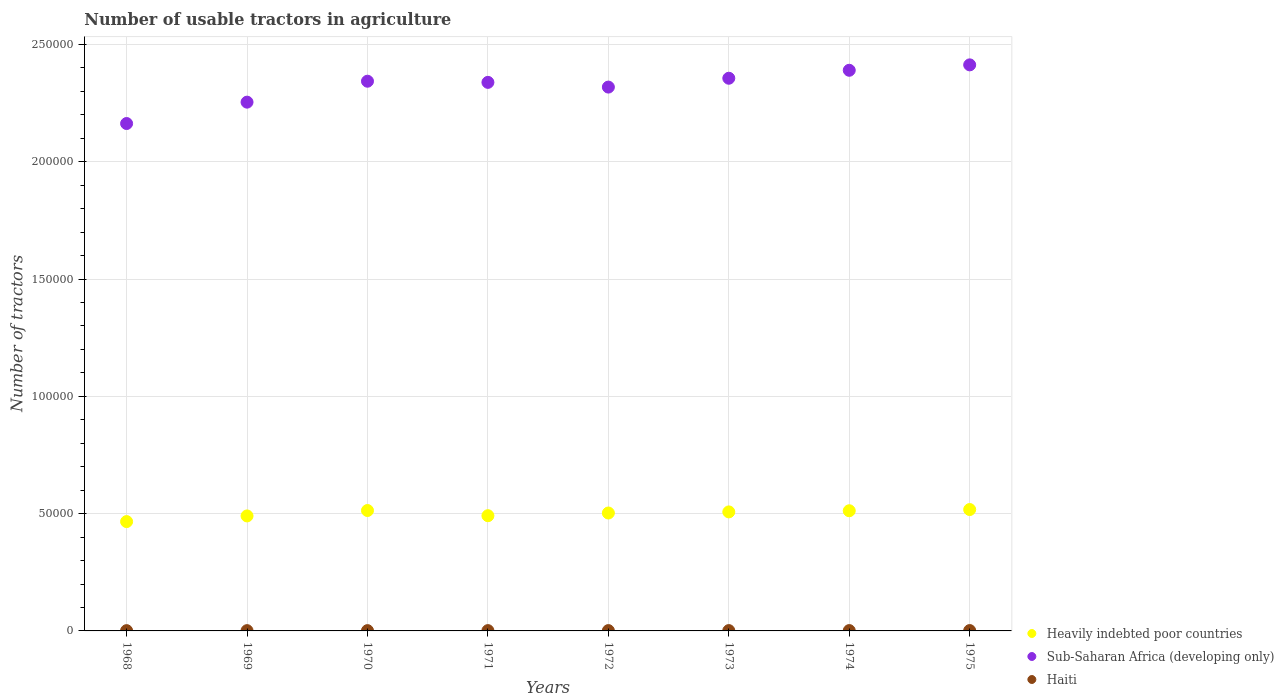Is the number of dotlines equal to the number of legend labels?
Provide a short and direct response. Yes. What is the number of usable tractors in agriculture in Haiti in 1973?
Provide a short and direct response. 140. Across all years, what is the maximum number of usable tractors in agriculture in Heavily indebted poor countries?
Provide a short and direct response. 5.17e+04. Across all years, what is the minimum number of usable tractors in agriculture in Sub-Saharan Africa (developing only)?
Provide a succinct answer. 2.16e+05. In which year was the number of usable tractors in agriculture in Heavily indebted poor countries maximum?
Your answer should be very brief. 1975. In which year was the number of usable tractors in agriculture in Sub-Saharan Africa (developing only) minimum?
Your response must be concise. 1968. What is the total number of usable tractors in agriculture in Sub-Saharan Africa (developing only) in the graph?
Provide a succinct answer. 1.86e+06. What is the difference between the number of usable tractors in agriculture in Sub-Saharan Africa (developing only) in 1969 and that in 1970?
Your response must be concise. -8924. What is the difference between the number of usable tractors in agriculture in Haiti in 1969 and the number of usable tractors in agriculture in Heavily indebted poor countries in 1972?
Ensure brevity in your answer.  -5.01e+04. What is the average number of usable tractors in agriculture in Heavily indebted poor countries per year?
Keep it short and to the point. 5.00e+04. In the year 1974, what is the difference between the number of usable tractors in agriculture in Haiti and number of usable tractors in agriculture in Heavily indebted poor countries?
Your answer should be very brief. -5.11e+04. In how many years, is the number of usable tractors in agriculture in Sub-Saharan Africa (developing only) greater than 40000?
Your answer should be very brief. 8. What is the ratio of the number of usable tractors in agriculture in Heavily indebted poor countries in 1972 to that in 1974?
Give a very brief answer. 0.98. Is the number of usable tractors in agriculture in Sub-Saharan Africa (developing only) in 1970 less than that in 1971?
Make the answer very short. No. Is the difference between the number of usable tractors in agriculture in Haiti in 1970 and 1971 greater than the difference between the number of usable tractors in agriculture in Heavily indebted poor countries in 1970 and 1971?
Provide a short and direct response. No. What is the difference between the highest and the second highest number of usable tractors in agriculture in Heavily indebted poor countries?
Offer a terse response. 417. What is the difference between the highest and the lowest number of usable tractors in agriculture in Heavily indebted poor countries?
Make the answer very short. 5139. In how many years, is the number of usable tractors in agriculture in Heavily indebted poor countries greater than the average number of usable tractors in agriculture in Heavily indebted poor countries taken over all years?
Provide a succinct answer. 5. Is the sum of the number of usable tractors in agriculture in Heavily indebted poor countries in 1970 and 1975 greater than the maximum number of usable tractors in agriculture in Haiti across all years?
Your answer should be very brief. Yes. Is it the case that in every year, the sum of the number of usable tractors in agriculture in Haiti and number of usable tractors in agriculture in Heavily indebted poor countries  is greater than the number of usable tractors in agriculture in Sub-Saharan Africa (developing only)?
Offer a very short reply. No. Is the number of usable tractors in agriculture in Sub-Saharan Africa (developing only) strictly less than the number of usable tractors in agriculture in Haiti over the years?
Give a very brief answer. No. How many dotlines are there?
Your answer should be compact. 3. How many years are there in the graph?
Offer a terse response. 8. What is the difference between two consecutive major ticks on the Y-axis?
Offer a very short reply. 5.00e+04. Does the graph contain grids?
Your response must be concise. Yes. How many legend labels are there?
Give a very brief answer. 3. What is the title of the graph?
Offer a terse response. Number of usable tractors in agriculture. Does "Serbia" appear as one of the legend labels in the graph?
Make the answer very short. No. What is the label or title of the Y-axis?
Your response must be concise. Number of tractors. What is the Number of tractors of Heavily indebted poor countries in 1968?
Your answer should be compact. 4.66e+04. What is the Number of tractors of Sub-Saharan Africa (developing only) in 1968?
Provide a short and direct response. 2.16e+05. What is the Number of tractors in Haiti in 1968?
Your answer should be compact. 115. What is the Number of tractors in Heavily indebted poor countries in 1969?
Your answer should be compact. 4.90e+04. What is the Number of tractors in Sub-Saharan Africa (developing only) in 1969?
Provide a succinct answer. 2.25e+05. What is the Number of tractors of Haiti in 1969?
Ensure brevity in your answer.  120. What is the Number of tractors of Heavily indebted poor countries in 1970?
Your response must be concise. 5.13e+04. What is the Number of tractors of Sub-Saharan Africa (developing only) in 1970?
Provide a short and direct response. 2.34e+05. What is the Number of tractors in Haiti in 1970?
Your response must be concise. 125. What is the Number of tractors in Heavily indebted poor countries in 1971?
Provide a short and direct response. 4.91e+04. What is the Number of tractors in Sub-Saharan Africa (developing only) in 1971?
Your response must be concise. 2.34e+05. What is the Number of tractors in Haiti in 1971?
Offer a terse response. 130. What is the Number of tractors in Heavily indebted poor countries in 1972?
Ensure brevity in your answer.  5.03e+04. What is the Number of tractors in Sub-Saharan Africa (developing only) in 1972?
Provide a short and direct response. 2.32e+05. What is the Number of tractors of Haiti in 1972?
Your answer should be very brief. 135. What is the Number of tractors of Heavily indebted poor countries in 1973?
Your response must be concise. 5.07e+04. What is the Number of tractors of Sub-Saharan Africa (developing only) in 1973?
Your response must be concise. 2.36e+05. What is the Number of tractors in Haiti in 1973?
Your answer should be compact. 140. What is the Number of tractors of Heavily indebted poor countries in 1974?
Keep it short and to the point. 5.12e+04. What is the Number of tractors in Sub-Saharan Africa (developing only) in 1974?
Provide a short and direct response. 2.39e+05. What is the Number of tractors in Haiti in 1974?
Give a very brief answer. 145. What is the Number of tractors in Heavily indebted poor countries in 1975?
Provide a succinct answer. 5.17e+04. What is the Number of tractors in Sub-Saharan Africa (developing only) in 1975?
Provide a succinct answer. 2.41e+05. What is the Number of tractors in Haiti in 1975?
Offer a very short reply. 150. Across all years, what is the maximum Number of tractors of Heavily indebted poor countries?
Make the answer very short. 5.17e+04. Across all years, what is the maximum Number of tractors in Sub-Saharan Africa (developing only)?
Your answer should be compact. 2.41e+05. Across all years, what is the maximum Number of tractors of Haiti?
Make the answer very short. 150. Across all years, what is the minimum Number of tractors of Heavily indebted poor countries?
Your answer should be compact. 4.66e+04. Across all years, what is the minimum Number of tractors in Sub-Saharan Africa (developing only)?
Make the answer very short. 2.16e+05. Across all years, what is the minimum Number of tractors in Haiti?
Your answer should be compact. 115. What is the total Number of tractors in Heavily indebted poor countries in the graph?
Provide a succinct answer. 4.00e+05. What is the total Number of tractors of Sub-Saharan Africa (developing only) in the graph?
Your answer should be compact. 1.86e+06. What is the total Number of tractors of Haiti in the graph?
Provide a short and direct response. 1060. What is the difference between the Number of tractors of Heavily indebted poor countries in 1968 and that in 1969?
Give a very brief answer. -2414. What is the difference between the Number of tractors of Sub-Saharan Africa (developing only) in 1968 and that in 1969?
Your answer should be very brief. -9111. What is the difference between the Number of tractors in Heavily indebted poor countries in 1968 and that in 1970?
Your answer should be compact. -4722. What is the difference between the Number of tractors of Sub-Saharan Africa (developing only) in 1968 and that in 1970?
Offer a very short reply. -1.80e+04. What is the difference between the Number of tractors in Haiti in 1968 and that in 1970?
Offer a terse response. -10. What is the difference between the Number of tractors in Heavily indebted poor countries in 1968 and that in 1971?
Provide a succinct answer. -2512. What is the difference between the Number of tractors of Sub-Saharan Africa (developing only) in 1968 and that in 1971?
Keep it short and to the point. -1.75e+04. What is the difference between the Number of tractors of Haiti in 1968 and that in 1971?
Offer a very short reply. -15. What is the difference between the Number of tractors of Heavily indebted poor countries in 1968 and that in 1972?
Your response must be concise. -3658. What is the difference between the Number of tractors in Sub-Saharan Africa (developing only) in 1968 and that in 1972?
Provide a short and direct response. -1.55e+04. What is the difference between the Number of tractors of Heavily indebted poor countries in 1968 and that in 1973?
Your answer should be compact. -4129. What is the difference between the Number of tractors in Sub-Saharan Africa (developing only) in 1968 and that in 1973?
Provide a short and direct response. -1.93e+04. What is the difference between the Number of tractors of Haiti in 1968 and that in 1973?
Ensure brevity in your answer.  -25. What is the difference between the Number of tractors of Heavily indebted poor countries in 1968 and that in 1974?
Provide a short and direct response. -4622. What is the difference between the Number of tractors in Sub-Saharan Africa (developing only) in 1968 and that in 1974?
Ensure brevity in your answer.  -2.27e+04. What is the difference between the Number of tractors of Heavily indebted poor countries in 1968 and that in 1975?
Provide a succinct answer. -5139. What is the difference between the Number of tractors in Sub-Saharan Africa (developing only) in 1968 and that in 1975?
Your response must be concise. -2.50e+04. What is the difference between the Number of tractors in Haiti in 1968 and that in 1975?
Provide a short and direct response. -35. What is the difference between the Number of tractors of Heavily indebted poor countries in 1969 and that in 1970?
Provide a succinct answer. -2308. What is the difference between the Number of tractors of Sub-Saharan Africa (developing only) in 1969 and that in 1970?
Offer a terse response. -8924. What is the difference between the Number of tractors in Haiti in 1969 and that in 1970?
Keep it short and to the point. -5. What is the difference between the Number of tractors in Heavily indebted poor countries in 1969 and that in 1971?
Provide a succinct answer. -98. What is the difference between the Number of tractors in Sub-Saharan Africa (developing only) in 1969 and that in 1971?
Your response must be concise. -8432. What is the difference between the Number of tractors of Haiti in 1969 and that in 1971?
Offer a very short reply. -10. What is the difference between the Number of tractors in Heavily indebted poor countries in 1969 and that in 1972?
Provide a succinct answer. -1244. What is the difference between the Number of tractors of Sub-Saharan Africa (developing only) in 1969 and that in 1972?
Give a very brief answer. -6420. What is the difference between the Number of tractors in Heavily indebted poor countries in 1969 and that in 1973?
Your answer should be compact. -1715. What is the difference between the Number of tractors of Sub-Saharan Africa (developing only) in 1969 and that in 1973?
Offer a terse response. -1.02e+04. What is the difference between the Number of tractors of Haiti in 1969 and that in 1973?
Keep it short and to the point. -20. What is the difference between the Number of tractors of Heavily indebted poor countries in 1969 and that in 1974?
Give a very brief answer. -2208. What is the difference between the Number of tractors in Sub-Saharan Africa (developing only) in 1969 and that in 1974?
Make the answer very short. -1.36e+04. What is the difference between the Number of tractors in Haiti in 1969 and that in 1974?
Give a very brief answer. -25. What is the difference between the Number of tractors in Heavily indebted poor countries in 1969 and that in 1975?
Make the answer very short. -2725. What is the difference between the Number of tractors in Sub-Saharan Africa (developing only) in 1969 and that in 1975?
Offer a very short reply. -1.59e+04. What is the difference between the Number of tractors in Haiti in 1969 and that in 1975?
Give a very brief answer. -30. What is the difference between the Number of tractors in Heavily indebted poor countries in 1970 and that in 1971?
Give a very brief answer. 2210. What is the difference between the Number of tractors of Sub-Saharan Africa (developing only) in 1970 and that in 1971?
Make the answer very short. 492. What is the difference between the Number of tractors in Heavily indebted poor countries in 1970 and that in 1972?
Your response must be concise. 1064. What is the difference between the Number of tractors of Sub-Saharan Africa (developing only) in 1970 and that in 1972?
Your answer should be compact. 2504. What is the difference between the Number of tractors in Heavily indebted poor countries in 1970 and that in 1973?
Keep it short and to the point. 593. What is the difference between the Number of tractors of Sub-Saharan Africa (developing only) in 1970 and that in 1973?
Provide a succinct answer. -1264. What is the difference between the Number of tractors of Haiti in 1970 and that in 1973?
Your answer should be compact. -15. What is the difference between the Number of tractors of Sub-Saharan Africa (developing only) in 1970 and that in 1974?
Provide a short and direct response. -4661. What is the difference between the Number of tractors of Haiti in 1970 and that in 1974?
Give a very brief answer. -20. What is the difference between the Number of tractors of Heavily indebted poor countries in 1970 and that in 1975?
Provide a short and direct response. -417. What is the difference between the Number of tractors in Sub-Saharan Africa (developing only) in 1970 and that in 1975?
Ensure brevity in your answer.  -6969. What is the difference between the Number of tractors of Haiti in 1970 and that in 1975?
Provide a succinct answer. -25. What is the difference between the Number of tractors of Heavily indebted poor countries in 1971 and that in 1972?
Your answer should be compact. -1146. What is the difference between the Number of tractors of Sub-Saharan Africa (developing only) in 1971 and that in 1972?
Make the answer very short. 2012. What is the difference between the Number of tractors of Haiti in 1971 and that in 1972?
Provide a succinct answer. -5. What is the difference between the Number of tractors in Heavily indebted poor countries in 1971 and that in 1973?
Offer a terse response. -1617. What is the difference between the Number of tractors in Sub-Saharan Africa (developing only) in 1971 and that in 1973?
Offer a very short reply. -1756. What is the difference between the Number of tractors in Heavily indebted poor countries in 1971 and that in 1974?
Provide a short and direct response. -2110. What is the difference between the Number of tractors in Sub-Saharan Africa (developing only) in 1971 and that in 1974?
Your answer should be very brief. -5153. What is the difference between the Number of tractors in Heavily indebted poor countries in 1971 and that in 1975?
Offer a very short reply. -2627. What is the difference between the Number of tractors in Sub-Saharan Africa (developing only) in 1971 and that in 1975?
Offer a very short reply. -7461. What is the difference between the Number of tractors in Haiti in 1971 and that in 1975?
Your answer should be compact. -20. What is the difference between the Number of tractors in Heavily indebted poor countries in 1972 and that in 1973?
Your answer should be very brief. -471. What is the difference between the Number of tractors in Sub-Saharan Africa (developing only) in 1972 and that in 1973?
Keep it short and to the point. -3768. What is the difference between the Number of tractors in Heavily indebted poor countries in 1972 and that in 1974?
Make the answer very short. -964. What is the difference between the Number of tractors of Sub-Saharan Africa (developing only) in 1972 and that in 1974?
Provide a succinct answer. -7165. What is the difference between the Number of tractors in Haiti in 1972 and that in 1974?
Provide a succinct answer. -10. What is the difference between the Number of tractors in Heavily indebted poor countries in 1972 and that in 1975?
Ensure brevity in your answer.  -1481. What is the difference between the Number of tractors in Sub-Saharan Africa (developing only) in 1972 and that in 1975?
Offer a very short reply. -9473. What is the difference between the Number of tractors in Heavily indebted poor countries in 1973 and that in 1974?
Ensure brevity in your answer.  -493. What is the difference between the Number of tractors in Sub-Saharan Africa (developing only) in 1973 and that in 1974?
Offer a very short reply. -3397. What is the difference between the Number of tractors in Haiti in 1973 and that in 1974?
Offer a terse response. -5. What is the difference between the Number of tractors of Heavily indebted poor countries in 1973 and that in 1975?
Give a very brief answer. -1010. What is the difference between the Number of tractors of Sub-Saharan Africa (developing only) in 1973 and that in 1975?
Ensure brevity in your answer.  -5705. What is the difference between the Number of tractors in Haiti in 1973 and that in 1975?
Your answer should be compact. -10. What is the difference between the Number of tractors in Heavily indebted poor countries in 1974 and that in 1975?
Keep it short and to the point. -517. What is the difference between the Number of tractors of Sub-Saharan Africa (developing only) in 1974 and that in 1975?
Offer a terse response. -2308. What is the difference between the Number of tractors in Heavily indebted poor countries in 1968 and the Number of tractors in Sub-Saharan Africa (developing only) in 1969?
Make the answer very short. -1.79e+05. What is the difference between the Number of tractors in Heavily indebted poor countries in 1968 and the Number of tractors in Haiti in 1969?
Ensure brevity in your answer.  4.65e+04. What is the difference between the Number of tractors of Sub-Saharan Africa (developing only) in 1968 and the Number of tractors of Haiti in 1969?
Offer a very short reply. 2.16e+05. What is the difference between the Number of tractors of Heavily indebted poor countries in 1968 and the Number of tractors of Sub-Saharan Africa (developing only) in 1970?
Provide a succinct answer. -1.88e+05. What is the difference between the Number of tractors of Heavily indebted poor countries in 1968 and the Number of tractors of Haiti in 1970?
Give a very brief answer. 4.65e+04. What is the difference between the Number of tractors in Sub-Saharan Africa (developing only) in 1968 and the Number of tractors in Haiti in 1970?
Offer a very short reply. 2.16e+05. What is the difference between the Number of tractors in Heavily indebted poor countries in 1968 and the Number of tractors in Sub-Saharan Africa (developing only) in 1971?
Your answer should be compact. -1.87e+05. What is the difference between the Number of tractors in Heavily indebted poor countries in 1968 and the Number of tractors in Haiti in 1971?
Keep it short and to the point. 4.65e+04. What is the difference between the Number of tractors of Sub-Saharan Africa (developing only) in 1968 and the Number of tractors of Haiti in 1971?
Your answer should be very brief. 2.16e+05. What is the difference between the Number of tractors in Heavily indebted poor countries in 1968 and the Number of tractors in Sub-Saharan Africa (developing only) in 1972?
Give a very brief answer. -1.85e+05. What is the difference between the Number of tractors of Heavily indebted poor countries in 1968 and the Number of tractors of Haiti in 1972?
Make the answer very short. 4.65e+04. What is the difference between the Number of tractors in Sub-Saharan Africa (developing only) in 1968 and the Number of tractors in Haiti in 1972?
Provide a succinct answer. 2.16e+05. What is the difference between the Number of tractors in Heavily indebted poor countries in 1968 and the Number of tractors in Sub-Saharan Africa (developing only) in 1973?
Provide a succinct answer. -1.89e+05. What is the difference between the Number of tractors in Heavily indebted poor countries in 1968 and the Number of tractors in Haiti in 1973?
Offer a very short reply. 4.65e+04. What is the difference between the Number of tractors in Sub-Saharan Africa (developing only) in 1968 and the Number of tractors in Haiti in 1973?
Ensure brevity in your answer.  2.16e+05. What is the difference between the Number of tractors in Heavily indebted poor countries in 1968 and the Number of tractors in Sub-Saharan Africa (developing only) in 1974?
Your answer should be compact. -1.92e+05. What is the difference between the Number of tractors in Heavily indebted poor countries in 1968 and the Number of tractors in Haiti in 1974?
Offer a terse response. 4.65e+04. What is the difference between the Number of tractors in Sub-Saharan Africa (developing only) in 1968 and the Number of tractors in Haiti in 1974?
Give a very brief answer. 2.16e+05. What is the difference between the Number of tractors of Heavily indebted poor countries in 1968 and the Number of tractors of Sub-Saharan Africa (developing only) in 1975?
Offer a terse response. -1.95e+05. What is the difference between the Number of tractors in Heavily indebted poor countries in 1968 and the Number of tractors in Haiti in 1975?
Provide a short and direct response. 4.65e+04. What is the difference between the Number of tractors in Sub-Saharan Africa (developing only) in 1968 and the Number of tractors in Haiti in 1975?
Provide a short and direct response. 2.16e+05. What is the difference between the Number of tractors in Heavily indebted poor countries in 1969 and the Number of tractors in Sub-Saharan Africa (developing only) in 1970?
Ensure brevity in your answer.  -1.85e+05. What is the difference between the Number of tractors of Heavily indebted poor countries in 1969 and the Number of tractors of Haiti in 1970?
Ensure brevity in your answer.  4.89e+04. What is the difference between the Number of tractors in Sub-Saharan Africa (developing only) in 1969 and the Number of tractors in Haiti in 1970?
Ensure brevity in your answer.  2.25e+05. What is the difference between the Number of tractors of Heavily indebted poor countries in 1969 and the Number of tractors of Sub-Saharan Africa (developing only) in 1971?
Make the answer very short. -1.85e+05. What is the difference between the Number of tractors of Heavily indebted poor countries in 1969 and the Number of tractors of Haiti in 1971?
Give a very brief answer. 4.89e+04. What is the difference between the Number of tractors in Sub-Saharan Africa (developing only) in 1969 and the Number of tractors in Haiti in 1971?
Ensure brevity in your answer.  2.25e+05. What is the difference between the Number of tractors in Heavily indebted poor countries in 1969 and the Number of tractors in Sub-Saharan Africa (developing only) in 1972?
Provide a short and direct response. -1.83e+05. What is the difference between the Number of tractors in Heavily indebted poor countries in 1969 and the Number of tractors in Haiti in 1972?
Provide a succinct answer. 4.89e+04. What is the difference between the Number of tractors in Sub-Saharan Africa (developing only) in 1969 and the Number of tractors in Haiti in 1972?
Keep it short and to the point. 2.25e+05. What is the difference between the Number of tractors in Heavily indebted poor countries in 1969 and the Number of tractors in Sub-Saharan Africa (developing only) in 1973?
Offer a terse response. -1.87e+05. What is the difference between the Number of tractors of Heavily indebted poor countries in 1969 and the Number of tractors of Haiti in 1973?
Make the answer very short. 4.89e+04. What is the difference between the Number of tractors of Sub-Saharan Africa (developing only) in 1969 and the Number of tractors of Haiti in 1973?
Offer a terse response. 2.25e+05. What is the difference between the Number of tractors of Heavily indebted poor countries in 1969 and the Number of tractors of Sub-Saharan Africa (developing only) in 1974?
Provide a short and direct response. -1.90e+05. What is the difference between the Number of tractors of Heavily indebted poor countries in 1969 and the Number of tractors of Haiti in 1974?
Ensure brevity in your answer.  4.89e+04. What is the difference between the Number of tractors in Sub-Saharan Africa (developing only) in 1969 and the Number of tractors in Haiti in 1974?
Make the answer very short. 2.25e+05. What is the difference between the Number of tractors of Heavily indebted poor countries in 1969 and the Number of tractors of Sub-Saharan Africa (developing only) in 1975?
Keep it short and to the point. -1.92e+05. What is the difference between the Number of tractors in Heavily indebted poor countries in 1969 and the Number of tractors in Haiti in 1975?
Provide a short and direct response. 4.89e+04. What is the difference between the Number of tractors of Sub-Saharan Africa (developing only) in 1969 and the Number of tractors of Haiti in 1975?
Make the answer very short. 2.25e+05. What is the difference between the Number of tractors of Heavily indebted poor countries in 1970 and the Number of tractors of Sub-Saharan Africa (developing only) in 1971?
Ensure brevity in your answer.  -1.83e+05. What is the difference between the Number of tractors of Heavily indebted poor countries in 1970 and the Number of tractors of Haiti in 1971?
Ensure brevity in your answer.  5.12e+04. What is the difference between the Number of tractors in Sub-Saharan Africa (developing only) in 1970 and the Number of tractors in Haiti in 1971?
Offer a terse response. 2.34e+05. What is the difference between the Number of tractors in Heavily indebted poor countries in 1970 and the Number of tractors in Sub-Saharan Africa (developing only) in 1972?
Offer a very short reply. -1.80e+05. What is the difference between the Number of tractors in Heavily indebted poor countries in 1970 and the Number of tractors in Haiti in 1972?
Offer a terse response. 5.12e+04. What is the difference between the Number of tractors in Sub-Saharan Africa (developing only) in 1970 and the Number of tractors in Haiti in 1972?
Ensure brevity in your answer.  2.34e+05. What is the difference between the Number of tractors of Heavily indebted poor countries in 1970 and the Number of tractors of Sub-Saharan Africa (developing only) in 1973?
Provide a short and direct response. -1.84e+05. What is the difference between the Number of tractors in Heavily indebted poor countries in 1970 and the Number of tractors in Haiti in 1973?
Your answer should be very brief. 5.12e+04. What is the difference between the Number of tractors in Sub-Saharan Africa (developing only) in 1970 and the Number of tractors in Haiti in 1973?
Ensure brevity in your answer.  2.34e+05. What is the difference between the Number of tractors in Heavily indebted poor countries in 1970 and the Number of tractors in Sub-Saharan Africa (developing only) in 1974?
Your response must be concise. -1.88e+05. What is the difference between the Number of tractors in Heavily indebted poor countries in 1970 and the Number of tractors in Haiti in 1974?
Offer a very short reply. 5.12e+04. What is the difference between the Number of tractors in Sub-Saharan Africa (developing only) in 1970 and the Number of tractors in Haiti in 1974?
Make the answer very short. 2.34e+05. What is the difference between the Number of tractors of Heavily indebted poor countries in 1970 and the Number of tractors of Sub-Saharan Africa (developing only) in 1975?
Your response must be concise. -1.90e+05. What is the difference between the Number of tractors in Heavily indebted poor countries in 1970 and the Number of tractors in Haiti in 1975?
Provide a succinct answer. 5.12e+04. What is the difference between the Number of tractors of Sub-Saharan Africa (developing only) in 1970 and the Number of tractors of Haiti in 1975?
Ensure brevity in your answer.  2.34e+05. What is the difference between the Number of tractors of Heavily indebted poor countries in 1971 and the Number of tractors of Sub-Saharan Africa (developing only) in 1972?
Your answer should be very brief. -1.83e+05. What is the difference between the Number of tractors of Heavily indebted poor countries in 1971 and the Number of tractors of Haiti in 1972?
Ensure brevity in your answer.  4.90e+04. What is the difference between the Number of tractors of Sub-Saharan Africa (developing only) in 1971 and the Number of tractors of Haiti in 1972?
Offer a terse response. 2.34e+05. What is the difference between the Number of tractors in Heavily indebted poor countries in 1971 and the Number of tractors in Sub-Saharan Africa (developing only) in 1973?
Give a very brief answer. -1.86e+05. What is the difference between the Number of tractors of Heavily indebted poor countries in 1971 and the Number of tractors of Haiti in 1973?
Provide a short and direct response. 4.90e+04. What is the difference between the Number of tractors of Sub-Saharan Africa (developing only) in 1971 and the Number of tractors of Haiti in 1973?
Your answer should be compact. 2.34e+05. What is the difference between the Number of tractors in Heavily indebted poor countries in 1971 and the Number of tractors in Sub-Saharan Africa (developing only) in 1974?
Give a very brief answer. -1.90e+05. What is the difference between the Number of tractors of Heavily indebted poor countries in 1971 and the Number of tractors of Haiti in 1974?
Offer a terse response. 4.90e+04. What is the difference between the Number of tractors of Sub-Saharan Africa (developing only) in 1971 and the Number of tractors of Haiti in 1974?
Provide a short and direct response. 2.34e+05. What is the difference between the Number of tractors of Heavily indebted poor countries in 1971 and the Number of tractors of Sub-Saharan Africa (developing only) in 1975?
Keep it short and to the point. -1.92e+05. What is the difference between the Number of tractors of Heavily indebted poor countries in 1971 and the Number of tractors of Haiti in 1975?
Keep it short and to the point. 4.90e+04. What is the difference between the Number of tractors of Sub-Saharan Africa (developing only) in 1971 and the Number of tractors of Haiti in 1975?
Offer a terse response. 2.34e+05. What is the difference between the Number of tractors of Heavily indebted poor countries in 1972 and the Number of tractors of Sub-Saharan Africa (developing only) in 1973?
Offer a terse response. -1.85e+05. What is the difference between the Number of tractors in Heavily indebted poor countries in 1972 and the Number of tractors in Haiti in 1973?
Ensure brevity in your answer.  5.01e+04. What is the difference between the Number of tractors of Sub-Saharan Africa (developing only) in 1972 and the Number of tractors of Haiti in 1973?
Offer a very short reply. 2.32e+05. What is the difference between the Number of tractors in Heavily indebted poor countries in 1972 and the Number of tractors in Sub-Saharan Africa (developing only) in 1974?
Offer a terse response. -1.89e+05. What is the difference between the Number of tractors of Heavily indebted poor countries in 1972 and the Number of tractors of Haiti in 1974?
Offer a very short reply. 5.01e+04. What is the difference between the Number of tractors in Sub-Saharan Africa (developing only) in 1972 and the Number of tractors in Haiti in 1974?
Provide a succinct answer. 2.32e+05. What is the difference between the Number of tractors in Heavily indebted poor countries in 1972 and the Number of tractors in Sub-Saharan Africa (developing only) in 1975?
Your answer should be compact. -1.91e+05. What is the difference between the Number of tractors in Heavily indebted poor countries in 1972 and the Number of tractors in Haiti in 1975?
Offer a very short reply. 5.01e+04. What is the difference between the Number of tractors in Sub-Saharan Africa (developing only) in 1972 and the Number of tractors in Haiti in 1975?
Provide a succinct answer. 2.32e+05. What is the difference between the Number of tractors in Heavily indebted poor countries in 1973 and the Number of tractors in Sub-Saharan Africa (developing only) in 1974?
Provide a short and direct response. -1.88e+05. What is the difference between the Number of tractors of Heavily indebted poor countries in 1973 and the Number of tractors of Haiti in 1974?
Offer a very short reply. 5.06e+04. What is the difference between the Number of tractors of Sub-Saharan Africa (developing only) in 1973 and the Number of tractors of Haiti in 1974?
Your response must be concise. 2.35e+05. What is the difference between the Number of tractors in Heavily indebted poor countries in 1973 and the Number of tractors in Sub-Saharan Africa (developing only) in 1975?
Your answer should be compact. -1.91e+05. What is the difference between the Number of tractors of Heavily indebted poor countries in 1973 and the Number of tractors of Haiti in 1975?
Your response must be concise. 5.06e+04. What is the difference between the Number of tractors of Sub-Saharan Africa (developing only) in 1973 and the Number of tractors of Haiti in 1975?
Keep it short and to the point. 2.35e+05. What is the difference between the Number of tractors in Heavily indebted poor countries in 1974 and the Number of tractors in Sub-Saharan Africa (developing only) in 1975?
Your response must be concise. -1.90e+05. What is the difference between the Number of tractors in Heavily indebted poor countries in 1974 and the Number of tractors in Haiti in 1975?
Your answer should be very brief. 5.11e+04. What is the difference between the Number of tractors of Sub-Saharan Africa (developing only) in 1974 and the Number of tractors of Haiti in 1975?
Give a very brief answer. 2.39e+05. What is the average Number of tractors of Heavily indebted poor countries per year?
Make the answer very short. 5.00e+04. What is the average Number of tractors in Sub-Saharan Africa (developing only) per year?
Make the answer very short. 2.32e+05. What is the average Number of tractors of Haiti per year?
Provide a short and direct response. 132.5. In the year 1968, what is the difference between the Number of tractors of Heavily indebted poor countries and Number of tractors of Sub-Saharan Africa (developing only)?
Your response must be concise. -1.70e+05. In the year 1968, what is the difference between the Number of tractors of Heavily indebted poor countries and Number of tractors of Haiti?
Make the answer very short. 4.65e+04. In the year 1968, what is the difference between the Number of tractors of Sub-Saharan Africa (developing only) and Number of tractors of Haiti?
Keep it short and to the point. 2.16e+05. In the year 1969, what is the difference between the Number of tractors of Heavily indebted poor countries and Number of tractors of Sub-Saharan Africa (developing only)?
Ensure brevity in your answer.  -1.76e+05. In the year 1969, what is the difference between the Number of tractors of Heavily indebted poor countries and Number of tractors of Haiti?
Provide a succinct answer. 4.89e+04. In the year 1969, what is the difference between the Number of tractors in Sub-Saharan Africa (developing only) and Number of tractors in Haiti?
Your response must be concise. 2.25e+05. In the year 1970, what is the difference between the Number of tractors in Heavily indebted poor countries and Number of tractors in Sub-Saharan Africa (developing only)?
Your answer should be compact. -1.83e+05. In the year 1970, what is the difference between the Number of tractors in Heavily indebted poor countries and Number of tractors in Haiti?
Provide a succinct answer. 5.12e+04. In the year 1970, what is the difference between the Number of tractors of Sub-Saharan Africa (developing only) and Number of tractors of Haiti?
Keep it short and to the point. 2.34e+05. In the year 1971, what is the difference between the Number of tractors in Heavily indebted poor countries and Number of tractors in Sub-Saharan Africa (developing only)?
Offer a terse response. -1.85e+05. In the year 1971, what is the difference between the Number of tractors of Heavily indebted poor countries and Number of tractors of Haiti?
Offer a very short reply. 4.90e+04. In the year 1971, what is the difference between the Number of tractors of Sub-Saharan Africa (developing only) and Number of tractors of Haiti?
Your response must be concise. 2.34e+05. In the year 1972, what is the difference between the Number of tractors in Heavily indebted poor countries and Number of tractors in Sub-Saharan Africa (developing only)?
Provide a succinct answer. -1.82e+05. In the year 1972, what is the difference between the Number of tractors of Heavily indebted poor countries and Number of tractors of Haiti?
Your response must be concise. 5.01e+04. In the year 1972, what is the difference between the Number of tractors of Sub-Saharan Africa (developing only) and Number of tractors of Haiti?
Give a very brief answer. 2.32e+05. In the year 1973, what is the difference between the Number of tractors in Heavily indebted poor countries and Number of tractors in Sub-Saharan Africa (developing only)?
Ensure brevity in your answer.  -1.85e+05. In the year 1973, what is the difference between the Number of tractors of Heavily indebted poor countries and Number of tractors of Haiti?
Provide a short and direct response. 5.06e+04. In the year 1973, what is the difference between the Number of tractors of Sub-Saharan Africa (developing only) and Number of tractors of Haiti?
Your response must be concise. 2.35e+05. In the year 1974, what is the difference between the Number of tractors of Heavily indebted poor countries and Number of tractors of Sub-Saharan Africa (developing only)?
Give a very brief answer. -1.88e+05. In the year 1974, what is the difference between the Number of tractors in Heavily indebted poor countries and Number of tractors in Haiti?
Your answer should be compact. 5.11e+04. In the year 1974, what is the difference between the Number of tractors in Sub-Saharan Africa (developing only) and Number of tractors in Haiti?
Offer a terse response. 2.39e+05. In the year 1975, what is the difference between the Number of tractors in Heavily indebted poor countries and Number of tractors in Sub-Saharan Africa (developing only)?
Keep it short and to the point. -1.90e+05. In the year 1975, what is the difference between the Number of tractors of Heavily indebted poor countries and Number of tractors of Haiti?
Keep it short and to the point. 5.16e+04. In the year 1975, what is the difference between the Number of tractors of Sub-Saharan Africa (developing only) and Number of tractors of Haiti?
Offer a very short reply. 2.41e+05. What is the ratio of the Number of tractors in Heavily indebted poor countries in 1968 to that in 1969?
Make the answer very short. 0.95. What is the ratio of the Number of tractors in Sub-Saharan Africa (developing only) in 1968 to that in 1969?
Provide a succinct answer. 0.96. What is the ratio of the Number of tractors of Haiti in 1968 to that in 1969?
Offer a terse response. 0.96. What is the ratio of the Number of tractors in Heavily indebted poor countries in 1968 to that in 1970?
Offer a terse response. 0.91. What is the ratio of the Number of tractors in Sub-Saharan Africa (developing only) in 1968 to that in 1970?
Provide a short and direct response. 0.92. What is the ratio of the Number of tractors of Heavily indebted poor countries in 1968 to that in 1971?
Your response must be concise. 0.95. What is the ratio of the Number of tractors of Sub-Saharan Africa (developing only) in 1968 to that in 1971?
Ensure brevity in your answer.  0.93. What is the ratio of the Number of tractors in Haiti in 1968 to that in 1971?
Provide a short and direct response. 0.88. What is the ratio of the Number of tractors of Heavily indebted poor countries in 1968 to that in 1972?
Provide a short and direct response. 0.93. What is the ratio of the Number of tractors of Sub-Saharan Africa (developing only) in 1968 to that in 1972?
Ensure brevity in your answer.  0.93. What is the ratio of the Number of tractors in Haiti in 1968 to that in 1972?
Ensure brevity in your answer.  0.85. What is the ratio of the Number of tractors of Heavily indebted poor countries in 1968 to that in 1973?
Your response must be concise. 0.92. What is the ratio of the Number of tractors in Sub-Saharan Africa (developing only) in 1968 to that in 1973?
Make the answer very short. 0.92. What is the ratio of the Number of tractors in Haiti in 1968 to that in 1973?
Your answer should be very brief. 0.82. What is the ratio of the Number of tractors of Heavily indebted poor countries in 1968 to that in 1974?
Make the answer very short. 0.91. What is the ratio of the Number of tractors of Sub-Saharan Africa (developing only) in 1968 to that in 1974?
Give a very brief answer. 0.91. What is the ratio of the Number of tractors of Haiti in 1968 to that in 1974?
Your response must be concise. 0.79. What is the ratio of the Number of tractors in Heavily indebted poor countries in 1968 to that in 1975?
Offer a very short reply. 0.9. What is the ratio of the Number of tractors in Sub-Saharan Africa (developing only) in 1968 to that in 1975?
Ensure brevity in your answer.  0.9. What is the ratio of the Number of tractors of Haiti in 1968 to that in 1975?
Your answer should be very brief. 0.77. What is the ratio of the Number of tractors in Heavily indebted poor countries in 1969 to that in 1970?
Your response must be concise. 0.95. What is the ratio of the Number of tractors in Sub-Saharan Africa (developing only) in 1969 to that in 1970?
Ensure brevity in your answer.  0.96. What is the ratio of the Number of tractors in Haiti in 1969 to that in 1970?
Keep it short and to the point. 0.96. What is the ratio of the Number of tractors of Sub-Saharan Africa (developing only) in 1969 to that in 1971?
Ensure brevity in your answer.  0.96. What is the ratio of the Number of tractors of Heavily indebted poor countries in 1969 to that in 1972?
Your answer should be very brief. 0.98. What is the ratio of the Number of tractors of Sub-Saharan Africa (developing only) in 1969 to that in 1972?
Keep it short and to the point. 0.97. What is the ratio of the Number of tractors in Heavily indebted poor countries in 1969 to that in 1973?
Make the answer very short. 0.97. What is the ratio of the Number of tractors of Sub-Saharan Africa (developing only) in 1969 to that in 1973?
Offer a very short reply. 0.96. What is the ratio of the Number of tractors in Heavily indebted poor countries in 1969 to that in 1974?
Ensure brevity in your answer.  0.96. What is the ratio of the Number of tractors of Sub-Saharan Africa (developing only) in 1969 to that in 1974?
Ensure brevity in your answer.  0.94. What is the ratio of the Number of tractors of Haiti in 1969 to that in 1974?
Keep it short and to the point. 0.83. What is the ratio of the Number of tractors of Heavily indebted poor countries in 1969 to that in 1975?
Your answer should be very brief. 0.95. What is the ratio of the Number of tractors in Sub-Saharan Africa (developing only) in 1969 to that in 1975?
Give a very brief answer. 0.93. What is the ratio of the Number of tractors in Haiti in 1969 to that in 1975?
Keep it short and to the point. 0.8. What is the ratio of the Number of tractors in Heavily indebted poor countries in 1970 to that in 1971?
Your answer should be compact. 1.04. What is the ratio of the Number of tractors of Haiti in 1970 to that in 1971?
Provide a short and direct response. 0.96. What is the ratio of the Number of tractors of Heavily indebted poor countries in 1970 to that in 1972?
Provide a succinct answer. 1.02. What is the ratio of the Number of tractors in Sub-Saharan Africa (developing only) in 1970 to that in 1972?
Offer a very short reply. 1.01. What is the ratio of the Number of tractors of Haiti in 1970 to that in 1972?
Offer a very short reply. 0.93. What is the ratio of the Number of tractors of Heavily indebted poor countries in 1970 to that in 1973?
Offer a very short reply. 1.01. What is the ratio of the Number of tractors in Sub-Saharan Africa (developing only) in 1970 to that in 1973?
Keep it short and to the point. 0.99. What is the ratio of the Number of tractors in Haiti in 1970 to that in 1973?
Ensure brevity in your answer.  0.89. What is the ratio of the Number of tractors of Heavily indebted poor countries in 1970 to that in 1974?
Your answer should be compact. 1. What is the ratio of the Number of tractors of Sub-Saharan Africa (developing only) in 1970 to that in 1974?
Provide a short and direct response. 0.98. What is the ratio of the Number of tractors of Haiti in 1970 to that in 1974?
Offer a terse response. 0.86. What is the ratio of the Number of tractors in Heavily indebted poor countries in 1970 to that in 1975?
Your response must be concise. 0.99. What is the ratio of the Number of tractors in Sub-Saharan Africa (developing only) in 1970 to that in 1975?
Provide a short and direct response. 0.97. What is the ratio of the Number of tractors in Heavily indebted poor countries in 1971 to that in 1972?
Give a very brief answer. 0.98. What is the ratio of the Number of tractors in Sub-Saharan Africa (developing only) in 1971 to that in 1972?
Your answer should be very brief. 1.01. What is the ratio of the Number of tractors in Heavily indebted poor countries in 1971 to that in 1973?
Offer a very short reply. 0.97. What is the ratio of the Number of tractors in Heavily indebted poor countries in 1971 to that in 1974?
Your response must be concise. 0.96. What is the ratio of the Number of tractors in Sub-Saharan Africa (developing only) in 1971 to that in 1974?
Provide a short and direct response. 0.98. What is the ratio of the Number of tractors of Haiti in 1971 to that in 1974?
Offer a very short reply. 0.9. What is the ratio of the Number of tractors of Heavily indebted poor countries in 1971 to that in 1975?
Your answer should be very brief. 0.95. What is the ratio of the Number of tractors in Sub-Saharan Africa (developing only) in 1971 to that in 1975?
Offer a very short reply. 0.97. What is the ratio of the Number of tractors in Haiti in 1971 to that in 1975?
Provide a short and direct response. 0.87. What is the ratio of the Number of tractors in Sub-Saharan Africa (developing only) in 1972 to that in 1973?
Make the answer very short. 0.98. What is the ratio of the Number of tractors of Haiti in 1972 to that in 1973?
Your answer should be very brief. 0.96. What is the ratio of the Number of tractors of Heavily indebted poor countries in 1972 to that in 1974?
Keep it short and to the point. 0.98. What is the ratio of the Number of tractors in Haiti in 1972 to that in 1974?
Give a very brief answer. 0.93. What is the ratio of the Number of tractors of Heavily indebted poor countries in 1972 to that in 1975?
Provide a short and direct response. 0.97. What is the ratio of the Number of tractors of Sub-Saharan Africa (developing only) in 1972 to that in 1975?
Ensure brevity in your answer.  0.96. What is the ratio of the Number of tractors in Sub-Saharan Africa (developing only) in 1973 to that in 1974?
Keep it short and to the point. 0.99. What is the ratio of the Number of tractors in Haiti in 1973 to that in 1974?
Keep it short and to the point. 0.97. What is the ratio of the Number of tractors of Heavily indebted poor countries in 1973 to that in 1975?
Your answer should be compact. 0.98. What is the ratio of the Number of tractors of Sub-Saharan Africa (developing only) in 1973 to that in 1975?
Give a very brief answer. 0.98. What is the ratio of the Number of tractors in Haiti in 1973 to that in 1975?
Give a very brief answer. 0.93. What is the ratio of the Number of tractors in Heavily indebted poor countries in 1974 to that in 1975?
Make the answer very short. 0.99. What is the ratio of the Number of tractors in Haiti in 1974 to that in 1975?
Make the answer very short. 0.97. What is the difference between the highest and the second highest Number of tractors of Heavily indebted poor countries?
Provide a succinct answer. 417. What is the difference between the highest and the second highest Number of tractors of Sub-Saharan Africa (developing only)?
Keep it short and to the point. 2308. What is the difference between the highest and the second highest Number of tractors in Haiti?
Provide a short and direct response. 5. What is the difference between the highest and the lowest Number of tractors of Heavily indebted poor countries?
Provide a succinct answer. 5139. What is the difference between the highest and the lowest Number of tractors of Sub-Saharan Africa (developing only)?
Offer a very short reply. 2.50e+04. 